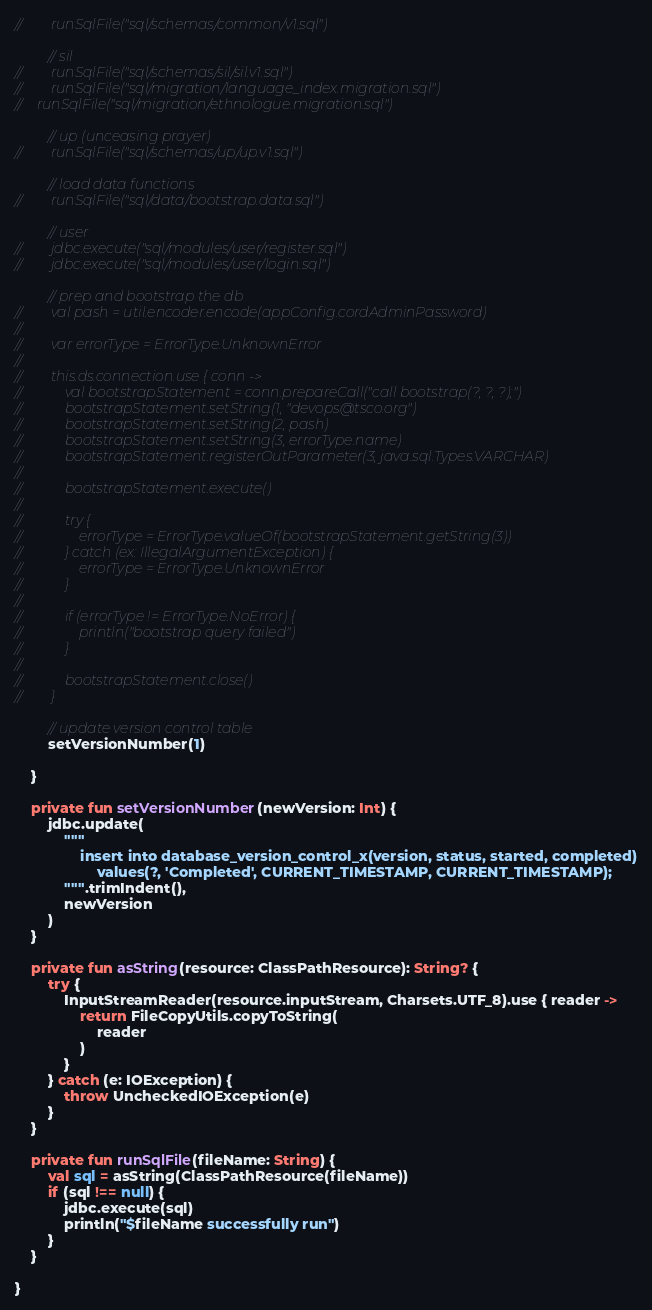<code> <loc_0><loc_0><loc_500><loc_500><_Kotlin_>//        runSqlFile("sql/schemas/common/v1.sql")

        // sil
//        runSqlFile("sql/schemas/sil/sil.v1.sql")
//        runSqlFile("sql/migration/language_index.migration.sql")
//    runSqlFile("sql/migration/ethnologue.migration.sql")

        // up (unceasing prayer)
//        runSqlFile("sql/schemas/up/up.v1.sql")

        // load data functions
//        runSqlFile("sql/data/bootstrap.data.sql")

        // user
//        jdbc.execute("sql/modules/user/register.sql")
//        jdbc.execute("sql/modules/user/login.sql")

        // prep and bootstrap the db
//        val pash = util.encoder.encode(appConfig.cordAdminPassword)
//
//        var errorType = ErrorType.UnknownError
//
//        this.ds.connection.use { conn ->
//            val bootstrapStatement = conn.prepareCall("call bootstrap(?, ?, ?);")
//            bootstrapStatement.setString(1, "devops@tsco.org")
//            bootstrapStatement.setString(2, pash)
//            bootstrapStatement.setString(3, errorType.name)
//            bootstrapStatement.registerOutParameter(3, java.sql.Types.VARCHAR)
//
//            bootstrapStatement.execute()
//
//            try {
//                errorType = ErrorType.valueOf(bootstrapStatement.getString(3))
//            } catch (ex: IllegalArgumentException) {
//                errorType = ErrorType.UnknownError
//            }
//
//            if (errorType != ErrorType.NoError) {
//                println("bootstrap query failed")
//            }
//
//            bootstrapStatement.close()
//        }

        // update version control table
        setVersionNumber(1)

    }

    private fun setVersionNumber(newVersion: Int) {
        jdbc.update(
            """
                insert into database_version_control_x(version, status, started, completed)
                    values(?, 'Completed', CURRENT_TIMESTAMP, CURRENT_TIMESTAMP);
            """.trimIndent(),
            newVersion
        )
    }

    private fun asString(resource: ClassPathResource): String? {
        try {
            InputStreamReader(resource.inputStream, Charsets.UTF_8).use { reader ->
                return FileCopyUtils.copyToString(
                    reader
                )
            }
        } catch (e: IOException) {
            throw UncheckedIOException(e)
        }
    }

    private fun runSqlFile(fileName: String) {
        val sql = asString(ClassPathResource(fileName))
        if (sql !== null) {
            jdbc.execute(sql)
            println("$fileName successfully run")
        }
    }

}</code> 